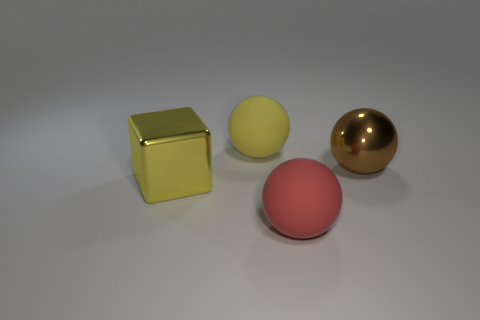What material is the big brown thing that is the same shape as the yellow matte thing?
Offer a very short reply. Metal. There is a ball behind the metallic thing that is to the right of the red thing; are there any large yellow metallic blocks right of it?
Your answer should be very brief. No. Is the material of the block the same as the big yellow ball that is behind the big brown ball?
Your response must be concise. No. What is the color of the rubber object behind the thing that is to the right of the red object?
Offer a very short reply. Yellow. Is there a big sphere of the same color as the big cube?
Make the answer very short. Yes. There is a yellow object in front of the rubber object behind the big metallic thing that is to the left of the red object; what is its size?
Provide a short and direct response. Large. Is the shape of the brown shiny thing the same as the large metal object in front of the large brown thing?
Keep it short and to the point. No. What number of other things are the same size as the yellow ball?
Make the answer very short. 3. There is a rubber thing in front of the large yellow metallic thing; how big is it?
Your answer should be very brief. Large. How many large balls have the same material as the large cube?
Your response must be concise. 1. 